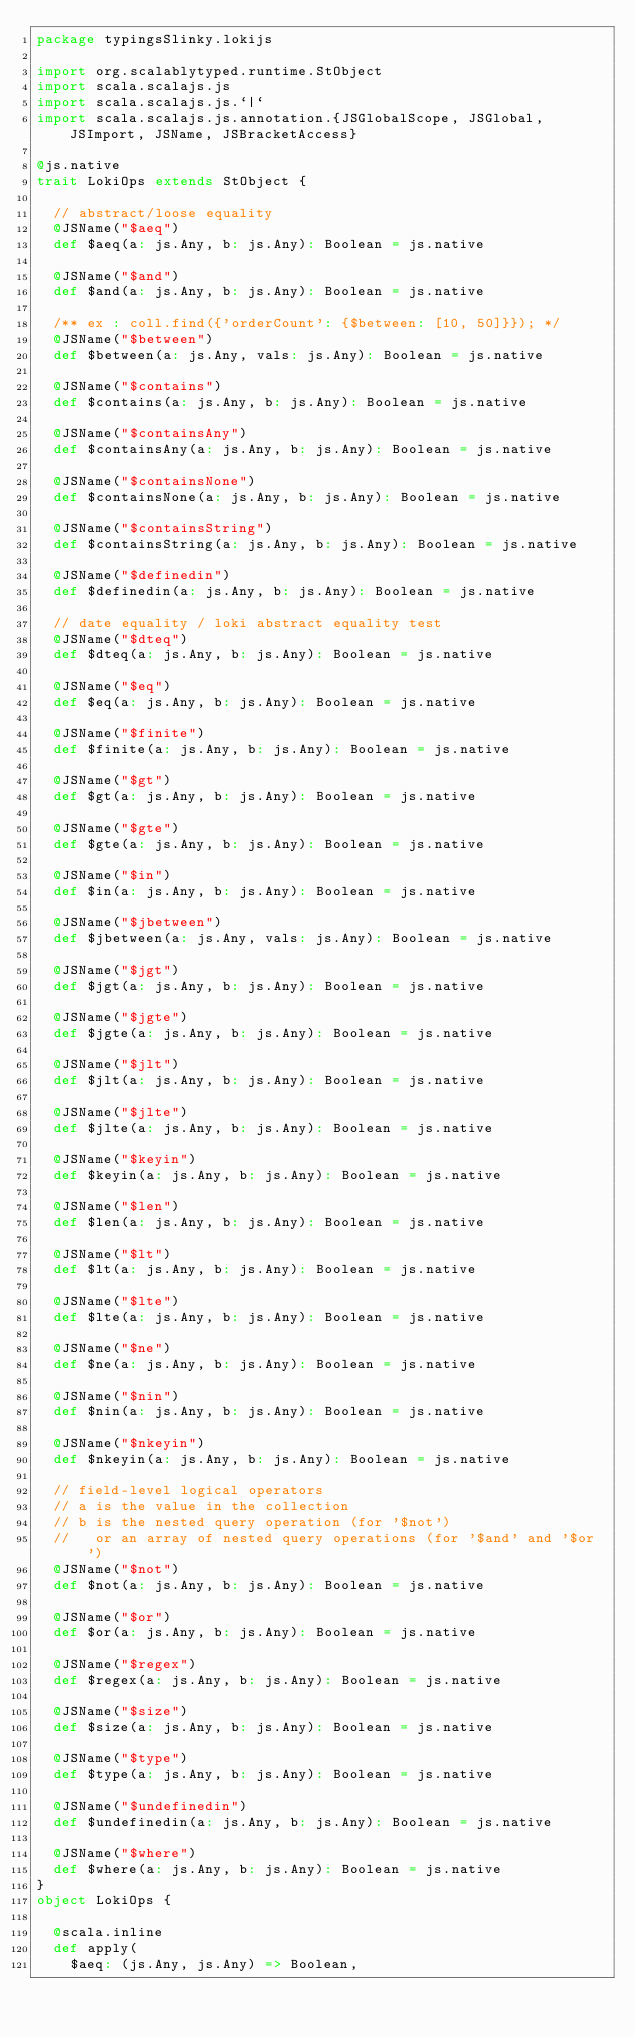Convert code to text. <code><loc_0><loc_0><loc_500><loc_500><_Scala_>package typingsSlinky.lokijs

import org.scalablytyped.runtime.StObject
import scala.scalajs.js
import scala.scalajs.js.`|`
import scala.scalajs.js.annotation.{JSGlobalScope, JSGlobal, JSImport, JSName, JSBracketAccess}

@js.native
trait LokiOps extends StObject {
  
  // abstract/loose equality
  @JSName("$aeq")
  def $aeq(a: js.Any, b: js.Any): Boolean = js.native
  
  @JSName("$and")
  def $and(a: js.Any, b: js.Any): Boolean = js.native
  
  /** ex : coll.find({'orderCount': {$between: [10, 50]}}); */
  @JSName("$between")
  def $between(a: js.Any, vals: js.Any): Boolean = js.native
  
  @JSName("$contains")
  def $contains(a: js.Any, b: js.Any): Boolean = js.native
  
  @JSName("$containsAny")
  def $containsAny(a: js.Any, b: js.Any): Boolean = js.native
  
  @JSName("$containsNone")
  def $containsNone(a: js.Any, b: js.Any): Boolean = js.native
  
  @JSName("$containsString")
  def $containsString(a: js.Any, b: js.Any): Boolean = js.native
  
  @JSName("$definedin")
  def $definedin(a: js.Any, b: js.Any): Boolean = js.native
  
  // date equality / loki abstract equality test
  @JSName("$dteq")
  def $dteq(a: js.Any, b: js.Any): Boolean = js.native
  
  @JSName("$eq")
  def $eq(a: js.Any, b: js.Any): Boolean = js.native
  
  @JSName("$finite")
  def $finite(a: js.Any, b: js.Any): Boolean = js.native
  
  @JSName("$gt")
  def $gt(a: js.Any, b: js.Any): Boolean = js.native
  
  @JSName("$gte")
  def $gte(a: js.Any, b: js.Any): Boolean = js.native
  
  @JSName("$in")
  def $in(a: js.Any, b: js.Any): Boolean = js.native
  
  @JSName("$jbetween")
  def $jbetween(a: js.Any, vals: js.Any): Boolean = js.native
  
  @JSName("$jgt")
  def $jgt(a: js.Any, b: js.Any): Boolean = js.native
  
  @JSName("$jgte")
  def $jgte(a: js.Any, b: js.Any): Boolean = js.native
  
  @JSName("$jlt")
  def $jlt(a: js.Any, b: js.Any): Boolean = js.native
  
  @JSName("$jlte")
  def $jlte(a: js.Any, b: js.Any): Boolean = js.native
  
  @JSName("$keyin")
  def $keyin(a: js.Any, b: js.Any): Boolean = js.native
  
  @JSName("$len")
  def $len(a: js.Any, b: js.Any): Boolean = js.native
  
  @JSName("$lt")
  def $lt(a: js.Any, b: js.Any): Boolean = js.native
  
  @JSName("$lte")
  def $lte(a: js.Any, b: js.Any): Boolean = js.native
  
  @JSName("$ne")
  def $ne(a: js.Any, b: js.Any): Boolean = js.native
  
  @JSName("$nin")
  def $nin(a: js.Any, b: js.Any): Boolean = js.native
  
  @JSName("$nkeyin")
  def $nkeyin(a: js.Any, b: js.Any): Boolean = js.native
  
  // field-level logical operators
  // a is the value in the collection
  // b is the nested query operation (for '$not')
  //   or an array of nested query operations (for '$and' and '$or')
  @JSName("$not")
  def $not(a: js.Any, b: js.Any): Boolean = js.native
  
  @JSName("$or")
  def $or(a: js.Any, b: js.Any): Boolean = js.native
  
  @JSName("$regex")
  def $regex(a: js.Any, b: js.Any): Boolean = js.native
  
  @JSName("$size")
  def $size(a: js.Any, b: js.Any): Boolean = js.native
  
  @JSName("$type")
  def $type(a: js.Any, b: js.Any): Boolean = js.native
  
  @JSName("$undefinedin")
  def $undefinedin(a: js.Any, b: js.Any): Boolean = js.native
  
  @JSName("$where")
  def $where(a: js.Any, b: js.Any): Boolean = js.native
}
object LokiOps {
  
  @scala.inline
  def apply(
    $aeq: (js.Any, js.Any) => Boolean,</code> 